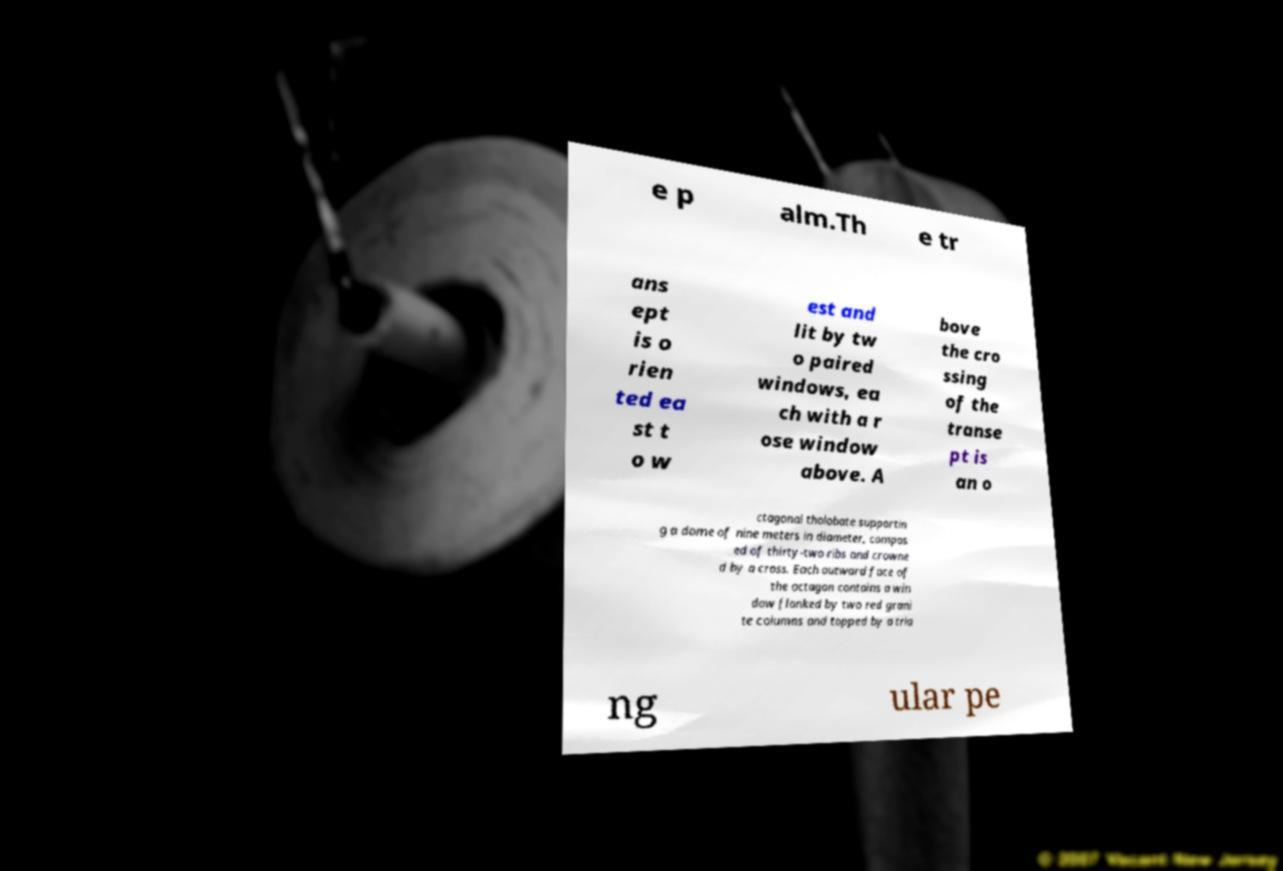Can you accurately transcribe the text from the provided image for me? e p alm.Th e tr ans ept is o rien ted ea st t o w est and lit by tw o paired windows, ea ch with a r ose window above. A bove the cro ssing of the transe pt is an o ctagonal tholobate supportin g a dome of nine meters in diameter, compos ed of thirty-two ribs and crowne d by a cross. Each outward face of the octagon contains a win dow flanked by two red grani te columns and topped by a tria ng ular pe 